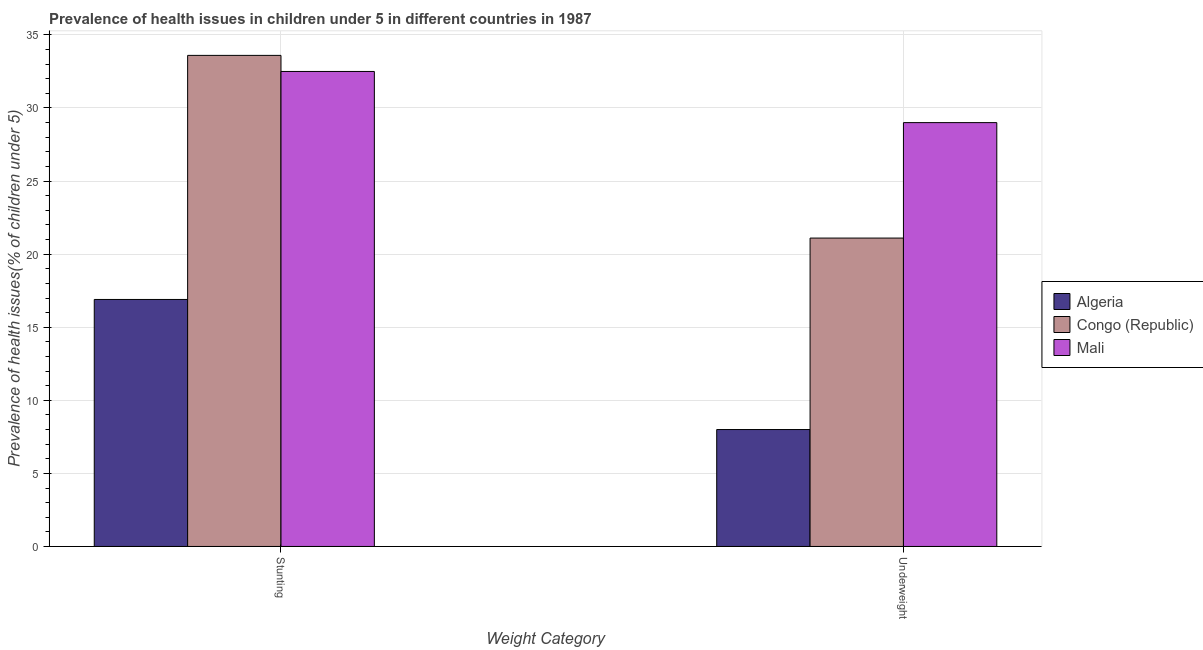How many different coloured bars are there?
Your answer should be compact. 3. Are the number of bars per tick equal to the number of legend labels?
Your response must be concise. Yes. What is the label of the 1st group of bars from the left?
Your answer should be very brief. Stunting. What is the percentage of stunted children in Algeria?
Your response must be concise. 16.9. Across all countries, what is the maximum percentage of stunted children?
Give a very brief answer. 33.6. Across all countries, what is the minimum percentage of stunted children?
Your answer should be compact. 16.9. In which country was the percentage of underweight children maximum?
Your response must be concise. Mali. In which country was the percentage of underweight children minimum?
Offer a very short reply. Algeria. What is the total percentage of stunted children in the graph?
Make the answer very short. 83. What is the difference between the percentage of underweight children in Algeria and that in Congo (Republic)?
Give a very brief answer. -13.1. What is the difference between the percentage of stunted children in Mali and the percentage of underweight children in Congo (Republic)?
Offer a very short reply. 11.4. What is the average percentage of underweight children per country?
Your answer should be very brief. 19.37. What is the difference between the percentage of underweight children and percentage of stunted children in Congo (Republic)?
Give a very brief answer. -12.5. In how many countries, is the percentage of stunted children greater than 6 %?
Give a very brief answer. 3. What is the ratio of the percentage of underweight children in Algeria to that in Congo (Republic)?
Provide a succinct answer. 0.38. In how many countries, is the percentage of underweight children greater than the average percentage of underweight children taken over all countries?
Your response must be concise. 2. What does the 2nd bar from the left in Underweight represents?
Provide a short and direct response. Congo (Republic). What does the 3rd bar from the right in Underweight represents?
Your answer should be very brief. Algeria. How many bars are there?
Provide a succinct answer. 6. Are all the bars in the graph horizontal?
Your answer should be very brief. No. How many countries are there in the graph?
Offer a terse response. 3. What is the difference between two consecutive major ticks on the Y-axis?
Offer a terse response. 5. Are the values on the major ticks of Y-axis written in scientific E-notation?
Your answer should be very brief. No. How many legend labels are there?
Offer a very short reply. 3. How are the legend labels stacked?
Ensure brevity in your answer.  Vertical. What is the title of the graph?
Your answer should be very brief. Prevalence of health issues in children under 5 in different countries in 1987. What is the label or title of the X-axis?
Give a very brief answer. Weight Category. What is the label or title of the Y-axis?
Ensure brevity in your answer.  Prevalence of health issues(% of children under 5). What is the Prevalence of health issues(% of children under 5) of Algeria in Stunting?
Keep it short and to the point. 16.9. What is the Prevalence of health issues(% of children under 5) in Congo (Republic) in Stunting?
Offer a very short reply. 33.6. What is the Prevalence of health issues(% of children under 5) of Mali in Stunting?
Offer a terse response. 32.5. What is the Prevalence of health issues(% of children under 5) of Algeria in Underweight?
Keep it short and to the point. 8. What is the Prevalence of health issues(% of children under 5) in Congo (Republic) in Underweight?
Offer a terse response. 21.1. Across all Weight Category, what is the maximum Prevalence of health issues(% of children under 5) of Algeria?
Offer a terse response. 16.9. Across all Weight Category, what is the maximum Prevalence of health issues(% of children under 5) in Congo (Republic)?
Ensure brevity in your answer.  33.6. Across all Weight Category, what is the maximum Prevalence of health issues(% of children under 5) in Mali?
Keep it short and to the point. 32.5. Across all Weight Category, what is the minimum Prevalence of health issues(% of children under 5) of Algeria?
Give a very brief answer. 8. Across all Weight Category, what is the minimum Prevalence of health issues(% of children under 5) of Congo (Republic)?
Make the answer very short. 21.1. Across all Weight Category, what is the minimum Prevalence of health issues(% of children under 5) in Mali?
Provide a succinct answer. 29. What is the total Prevalence of health issues(% of children under 5) of Algeria in the graph?
Your answer should be very brief. 24.9. What is the total Prevalence of health issues(% of children under 5) of Congo (Republic) in the graph?
Provide a succinct answer. 54.7. What is the total Prevalence of health issues(% of children under 5) of Mali in the graph?
Give a very brief answer. 61.5. What is the difference between the Prevalence of health issues(% of children under 5) of Mali in Stunting and that in Underweight?
Offer a terse response. 3.5. What is the difference between the Prevalence of health issues(% of children under 5) of Congo (Republic) in Stunting and the Prevalence of health issues(% of children under 5) of Mali in Underweight?
Ensure brevity in your answer.  4.6. What is the average Prevalence of health issues(% of children under 5) in Algeria per Weight Category?
Your response must be concise. 12.45. What is the average Prevalence of health issues(% of children under 5) of Congo (Republic) per Weight Category?
Keep it short and to the point. 27.35. What is the average Prevalence of health issues(% of children under 5) of Mali per Weight Category?
Provide a short and direct response. 30.75. What is the difference between the Prevalence of health issues(% of children under 5) of Algeria and Prevalence of health issues(% of children under 5) of Congo (Republic) in Stunting?
Make the answer very short. -16.7. What is the difference between the Prevalence of health issues(% of children under 5) of Algeria and Prevalence of health issues(% of children under 5) of Mali in Stunting?
Provide a short and direct response. -15.6. What is the difference between the Prevalence of health issues(% of children under 5) of Algeria and Prevalence of health issues(% of children under 5) of Congo (Republic) in Underweight?
Give a very brief answer. -13.1. What is the difference between the Prevalence of health issues(% of children under 5) of Algeria and Prevalence of health issues(% of children under 5) of Mali in Underweight?
Keep it short and to the point. -21. What is the ratio of the Prevalence of health issues(% of children under 5) in Algeria in Stunting to that in Underweight?
Your answer should be very brief. 2.11. What is the ratio of the Prevalence of health issues(% of children under 5) in Congo (Republic) in Stunting to that in Underweight?
Provide a short and direct response. 1.59. What is the ratio of the Prevalence of health issues(% of children under 5) of Mali in Stunting to that in Underweight?
Your response must be concise. 1.12. What is the difference between the highest and the second highest Prevalence of health issues(% of children under 5) of Algeria?
Your response must be concise. 8.9. What is the difference between the highest and the second highest Prevalence of health issues(% of children under 5) of Mali?
Provide a succinct answer. 3.5. What is the difference between the highest and the lowest Prevalence of health issues(% of children under 5) in Algeria?
Offer a terse response. 8.9. What is the difference between the highest and the lowest Prevalence of health issues(% of children under 5) in Congo (Republic)?
Make the answer very short. 12.5. What is the difference between the highest and the lowest Prevalence of health issues(% of children under 5) in Mali?
Make the answer very short. 3.5. 